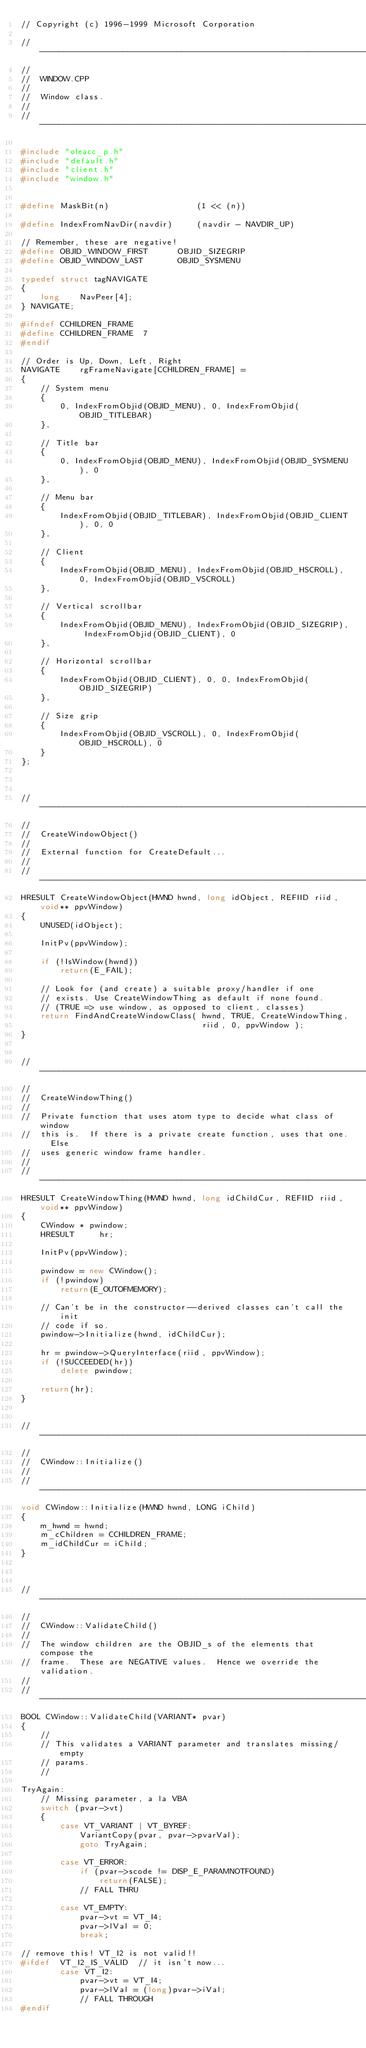<code> <loc_0><loc_0><loc_500><loc_500><_C++_>// Copyright (c) 1996-1999 Microsoft Corporation

// --------------------------------------------------------------------------
//
//  WINDOW.CPP
//
//  Window class.
//
// --------------------------------------------------------------------------

#include "oleacc_p.h"
#include "default.h"
#include "client.h"
#include "window.h"


#define MaskBit(n)                  (1 << (n))

#define IndexFromNavDir(navdir)     (navdir - NAVDIR_UP)

// Remember, these are negative!
#define OBJID_WINDOW_FIRST      OBJID_SIZEGRIP
#define OBJID_WINDOW_LAST       OBJID_SYSMENU

typedef struct tagNAVIGATE
{
    long    NavPeer[4];
} NAVIGATE;

#ifndef CCHILDREN_FRAME
#define CCHILDREN_FRAME  7
#endif

// Order is Up, Down, Left, Right
NAVIGATE    rgFrameNavigate[CCHILDREN_FRAME] =
{
    // System menu
    {
        0, IndexFromObjid(OBJID_MENU), 0, IndexFromObjid(OBJID_TITLEBAR)
    },

    // Title bar
    {
        0, IndexFromObjid(OBJID_MENU), IndexFromObjid(OBJID_SYSMENU), 0
    },

    // Menu bar
    {
        IndexFromObjid(OBJID_TITLEBAR), IndexFromObjid(OBJID_CLIENT), 0, 0
    },

    // Client
    {
        IndexFromObjid(OBJID_MENU), IndexFromObjid(OBJID_HSCROLL), 0, IndexFromObjid(OBJID_VSCROLL)
    },

    // Vertical scrollbar
    {
        IndexFromObjid(OBJID_MENU), IndexFromObjid(OBJID_SIZEGRIP), IndexFromObjid(OBJID_CLIENT), 0
    },

    // Horizontal scrollbar
    {
        IndexFromObjid(OBJID_CLIENT), 0, 0, IndexFromObjid(OBJID_SIZEGRIP)
    },

    // Size grip
    {
        IndexFromObjid(OBJID_VSCROLL), 0, IndexFromObjid(OBJID_HSCROLL), 0
    }
};



// --------------------------------------------------------------------------
//
//  CreateWindowObject()
//
//  External function for CreateDefault...
//
// --------------------------------------------------------------------------
HRESULT CreateWindowObject(HWND hwnd, long idObject, REFIID riid, void** ppvWindow)
{
    UNUSED(idObject);

    InitPv(ppvWindow);

    if (!IsWindow(hwnd))
        return(E_FAIL);

    // Look for (and create) a suitable proxy/handler if one
    // exists. Use CreateWindowThing as default if none found.
    // (TRUE => use window, as opposed to client, classes)
    return FindAndCreateWindowClass( hwnd, TRUE, CreateWindowThing,
                                     riid, 0, ppvWindow );
}


// --------------------------------------------------------------------------
//
//  CreateWindowThing()
//
//  Private function that uses atom type to decide what class of window
//  this is.  If there is a private create function, uses that one.  Else
//  uses generic window frame handler.
//
// --------------------------------------------------------------------------
HRESULT CreateWindowThing(HWND hwnd, long idChildCur, REFIID riid, void** ppvWindow)
{
    CWindow * pwindow;
    HRESULT     hr;

    InitPv(ppvWindow);

    pwindow = new CWindow();
    if (!pwindow)
        return(E_OUTOFMEMORY);

    // Can't be in the constructor--derived classes can't call the init
    // code if so.
    pwindow->Initialize(hwnd, idChildCur);

    hr = pwindow->QueryInterface(riid, ppvWindow);
    if (!SUCCEEDED(hr))
        delete pwindow;

    return(hr);
}


// --------------------------------------------------------------------------
//
//  CWindow::Initialize()
//
// --------------------------------------------------------------------------
void CWindow::Initialize(HWND hwnd, LONG iChild)
{
    m_hwnd = hwnd;
    m_cChildren = CCHILDREN_FRAME;
    m_idChildCur = iChild;
}



// --------------------------------------------------------------------------
//
//  CWindow::ValidateChild()
//
//  The window children are the OBJID_s of the elements that compose the
//  frame.  These are NEGATIVE values.  Hence we override the validation.
//
// --------------------------------------------------------------------------
BOOL CWindow::ValidateChild(VARIANT* pvar)
{
    //
    // This validates a VARIANT parameter and translates missing/empty
    // params.
    //

TryAgain:
    // Missing parameter, a la VBA
    switch (pvar->vt)
    {
        case VT_VARIANT | VT_BYREF:
            VariantCopy(pvar, pvar->pvarVal);
            goto TryAgain;

        case VT_ERROR:
            if (pvar->scode != DISP_E_PARAMNOTFOUND)
                return(FALSE);
            // FALL THRU

        case VT_EMPTY:
            pvar->vt = VT_I4;
            pvar->lVal = 0;
            break;

// remove this! VT_I2 is not valid!!
#ifdef  VT_I2_IS_VALID  // it isn't now...
        case VT_I2:
            pvar->vt = VT_I4;
            pvar->lVal = (long)pvar->iVal;
            // FALL THROUGH
#endif
</code> 